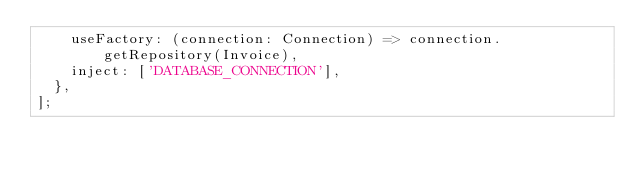Convert code to text. <code><loc_0><loc_0><loc_500><loc_500><_TypeScript_>    useFactory: (connection: Connection) => connection.getRepository(Invoice),
    inject: ['DATABASE_CONNECTION'],
  },
];
</code> 